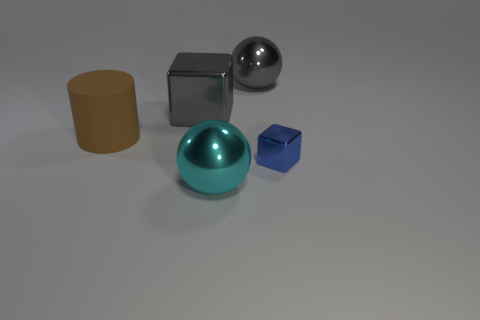Is there any other thing that is the same shape as the brown rubber object?
Your answer should be very brief. No. Are there fewer blue cubes behind the big brown object than large green metallic cylinders?
Your response must be concise. No. Do the big metal ball behind the cylinder and the big metal block have the same color?
Your answer should be very brief. Yes. How many metal things are large brown things or blue things?
Your answer should be very brief. 1. Are there any other things that are the same size as the blue thing?
Your response must be concise. No. The other ball that is the same material as the big cyan sphere is what color?
Your answer should be very brief. Gray. How many cubes are either tiny gray things or small objects?
Your answer should be compact. 1. What number of objects are either brown rubber things or objects behind the rubber cylinder?
Your response must be concise. 3. Is there a tiny brown rubber sphere?
Give a very brief answer. No. How many large shiny things have the same color as the large block?
Provide a succinct answer. 1. 